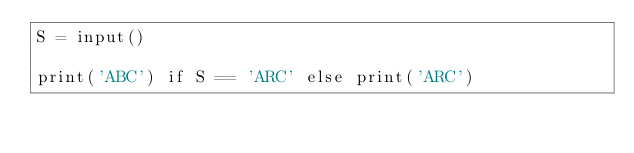Convert code to text. <code><loc_0><loc_0><loc_500><loc_500><_Python_>S = input()

print('ABC') if S == 'ARC' else print('ARC')</code> 